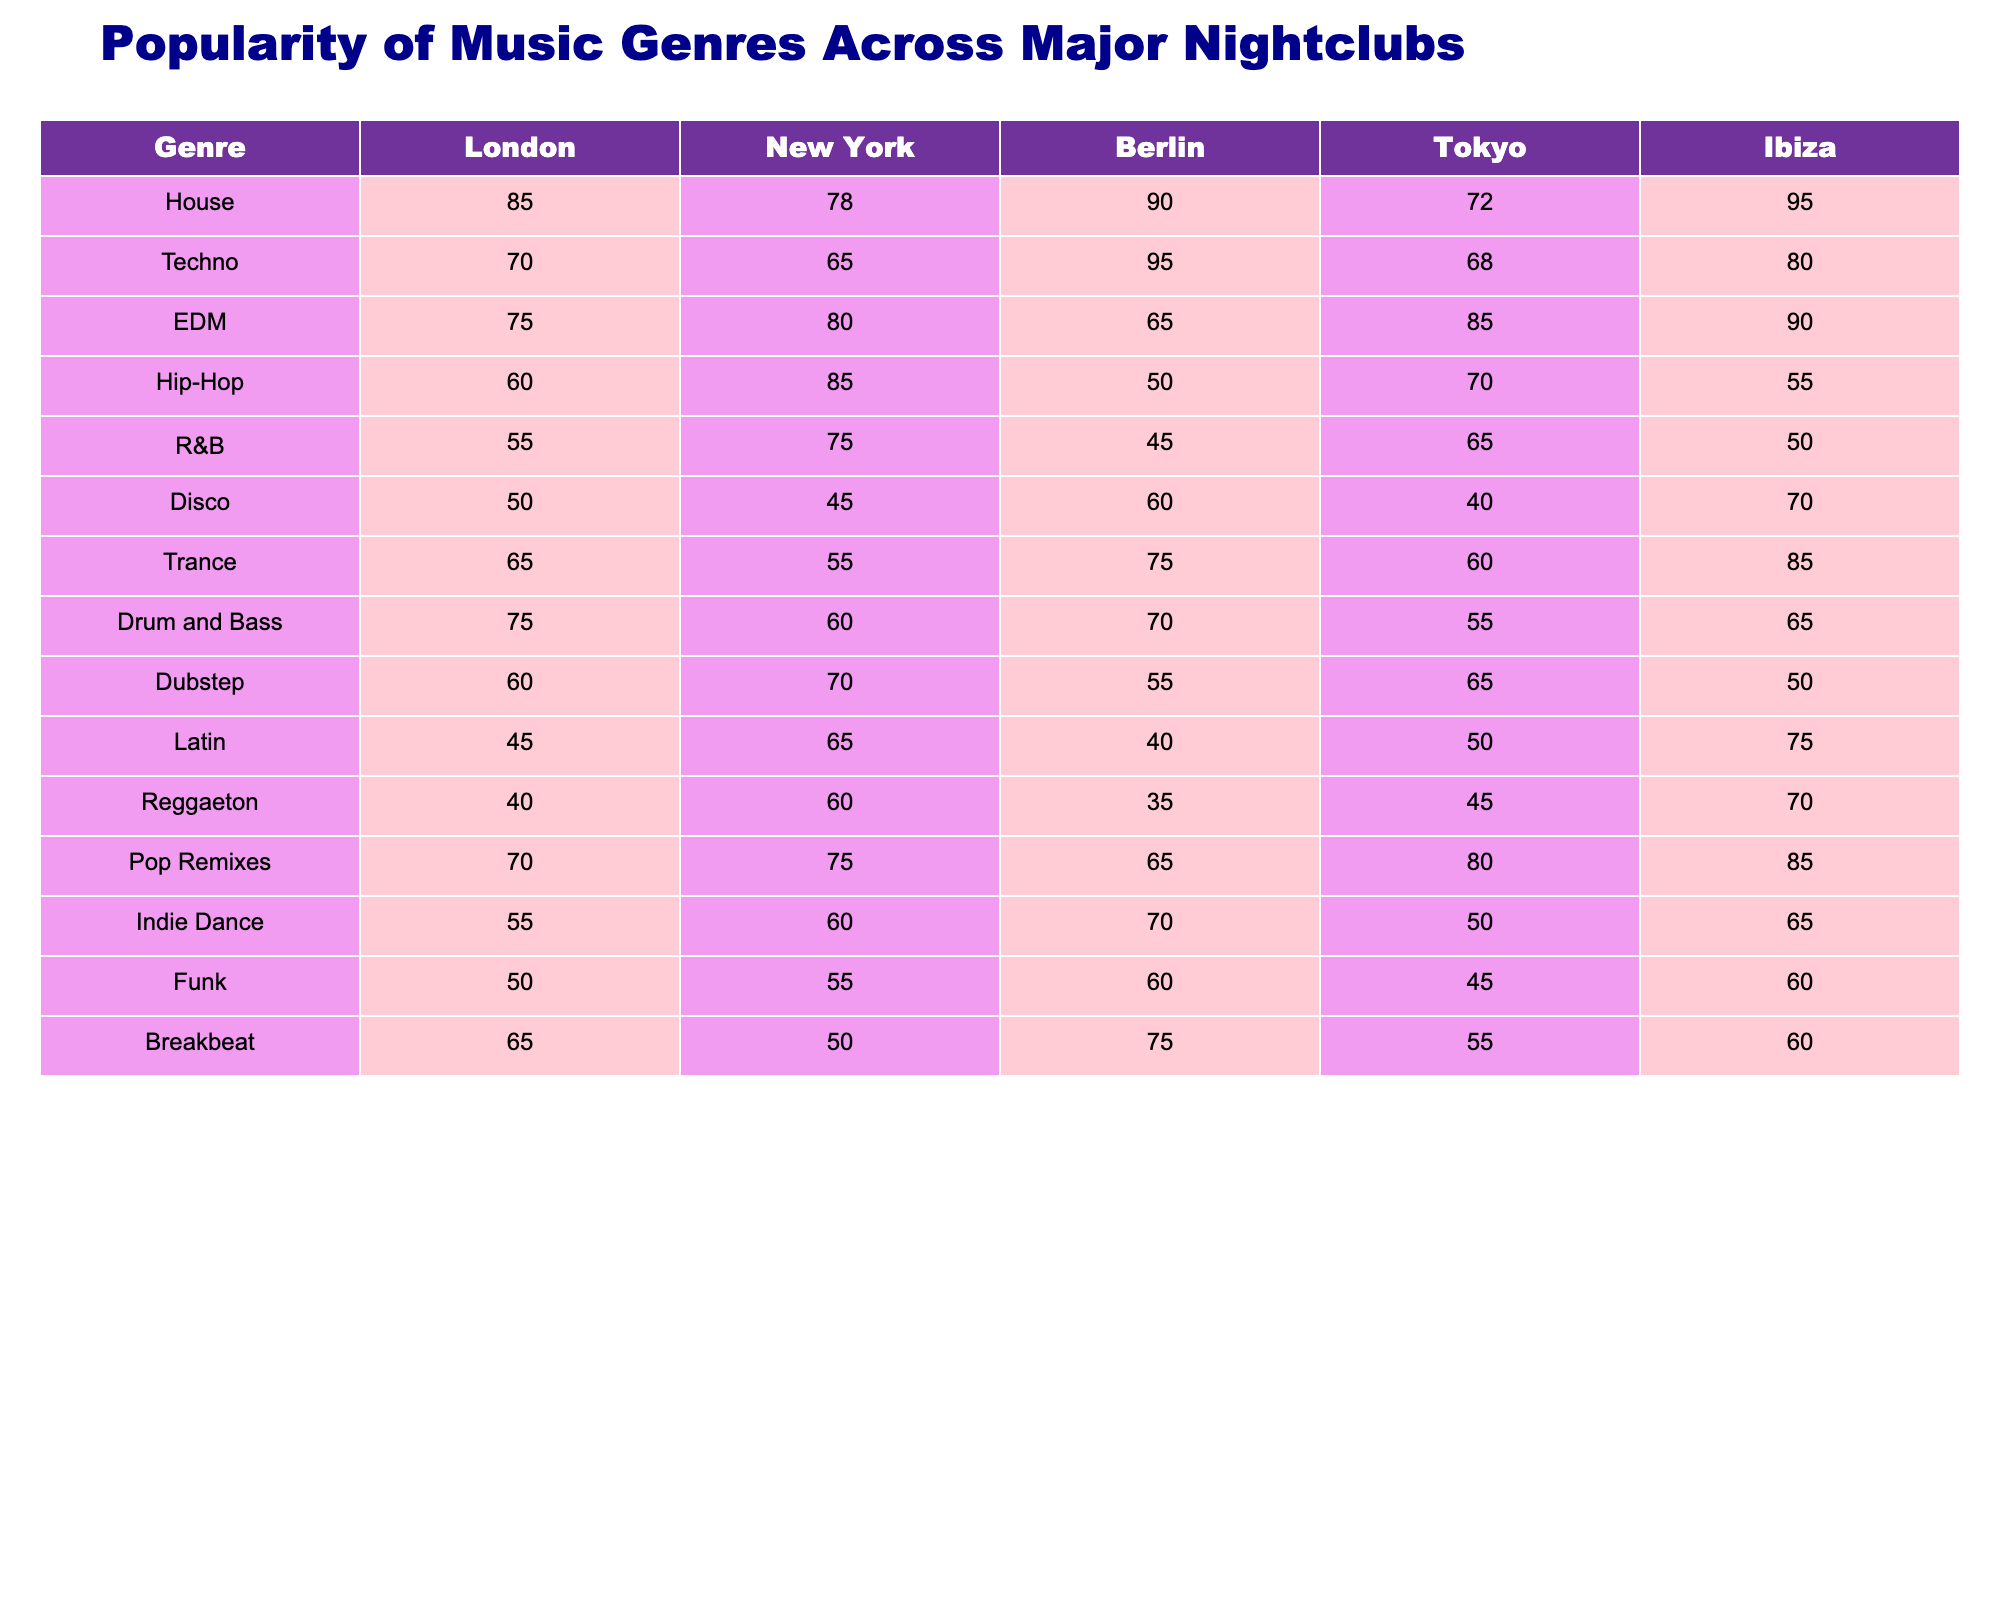What genre is the most popular in Ibiza? The highest value in the Ibiza column is 95 for the House genre, indicating that it is the most popular.
Answer: House Which city has the highest popularity for Techno? The highest value for Techno is 95, which is observed in Berlin.
Answer: Berlin What is the average popularity of EDM across all cities? The values for EDM in the cities are 75, 80, 65, 85, and 90. Summing these gives 395, and dividing by 5 gives an average of 79.
Answer: 79 Is Hip-Hop more popular in New York than in London? The popularity for Hip-Hop in New York is 85 and in London is 60; since 85 is greater than 60, Hip-Hop is indeed more popular in New York.
Answer: Yes Which genre has the lowest popularity in Tokyo? Looking at the Tokyo column, Latin has the lowest value at 50.
Answer: Latin What is the difference in popularity between House in Ibiza and Disco in London? House in Ibiza has a popularity of 95, while Disco in London has 50. The difference is 95 - 50 = 45.
Answer: 45 Which genre has the most consistent popularity across the cities? By observing the values of each genre, Funk has the lowest variation, with scores around 50-60, indicating more consistent popularity compared to others.
Answer: Funk What is the total popularity of R&B across all cities? The values for R&B are 55, 75, 45, 65, and 50. Summing these gives a total of 55 + 75 + 45 + 65 + 50 = 290.
Answer: 290 Which city shows the least interest in Disco? The lowest value for Disco appears in Tokyo, with a popularity score of 40.
Answer: Tokyo Among the genres, which one has the biggest difference in popularity between London and New York? By comparing the values, Hip-Hop shows the biggest difference: 85 in New York and 60 in London, giving a difference of 85 - 60 = 25.
Answer: Hip-Hop 